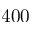Convert formula to latex. <formula><loc_0><loc_0><loc_500><loc_500>4 0 0</formula> 